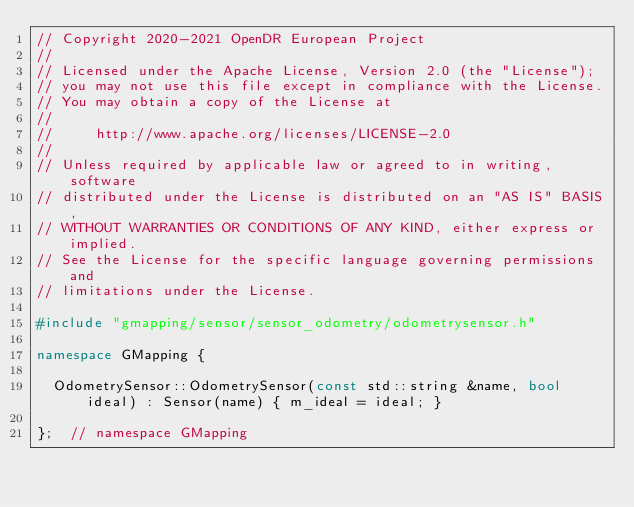Convert code to text. <code><loc_0><loc_0><loc_500><loc_500><_C++_>// Copyright 2020-2021 OpenDR European Project
//
// Licensed under the Apache License, Version 2.0 (the "License");
// you may not use this file except in compliance with the License.
// You may obtain a copy of the License at
//
//     http://www.apache.org/licenses/LICENSE-2.0
//
// Unless required by applicable law or agreed to in writing, software
// distributed under the License is distributed on an "AS IS" BASIS,
// WITHOUT WARRANTIES OR CONDITIONS OF ANY KIND, either express or implied.
// See the License for the specific language governing permissions and
// limitations under the License.

#include "gmapping/sensor/sensor_odometry/odometrysensor.h"

namespace GMapping {

  OdometrySensor::OdometrySensor(const std::string &name, bool ideal) : Sensor(name) { m_ideal = ideal; }

};  // namespace GMapping
</code> 